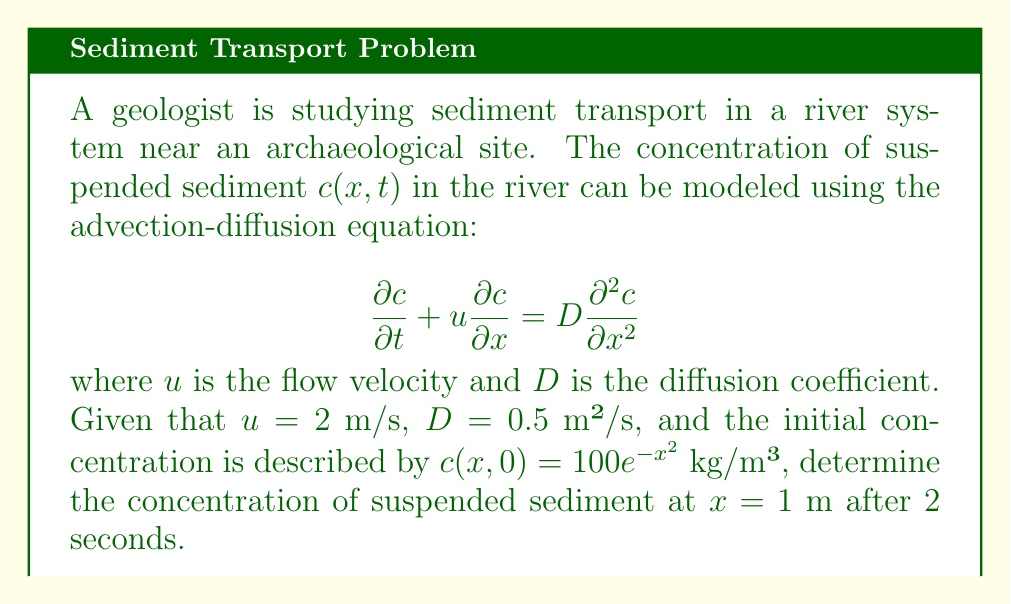Can you solve this math problem? To solve this problem, we need to use the solution to the advection-diffusion equation with the given initial condition. The general solution for this equation is:

$$c(x,t) = \frac{1}{\sqrt{4\pi Dt}} \int_{-\infty}^{\infty} c(\xi,0) \exp\left(-\frac{(x-\xi-ut)^2}{4Dt}\right) d\xi$$

where $c(\xi,0)$ is the initial concentration distribution.

Given:
- Initial concentration: $c(x,0) = 100e^{-x^2}$ kg/m³
- Flow velocity: $u = 2$ m/s
- Diffusion coefficient: $D = 0.5$ m²/s
- Time: $t = 2$ s
- Position: $x = 1$ m

Step 1: Substitute the given values into the general solution:

$$c(1,2) = \frac{1}{\sqrt{4\pi(0.5)(2)}} \int_{-\infty}^{\infty} 100e^{-\xi^2} \exp\left(-\frac{(1-\xi-2(2))^2}{4(0.5)(2)}\right) d\xi$$

Step 2: Simplify the expression:

$$c(1,2) = \frac{100}{\sqrt{2\pi}} \int_{-\infty}^{\infty} e^{-\xi^2} \exp\left(-\frac{(1-\xi-4)^2}{4}\right) d\xi$$

Step 3: Combine the exponents in the integrand:

$$c(1,2) = \frac{100}{\sqrt{2\pi}} \int_{-\infty}^{\infty} \exp\left(-\xi^2 - \frac{(1-\xi-4)^2}{4}\right) d\xi$$

Step 4: Complete the square for the exponent:

$$c(1,2) = \frac{100}{\sqrt{2\pi}} \int_{-\infty}^{\infty} \exp\left(-\frac{5}{4}\xi^2 + \frac{5}{2}\xi - \frac{25}{4}\right) d\xi$$

Step 5: Evaluate the integral:

$$c(1,2) = \frac{100}{\sqrt{2\pi}} \sqrt{\frac{4\pi}{5}} \exp\left(-\frac{5}{4}\right)$$

Step 6: Simplify the expression:

$$c(1,2) = \frac{100}{\sqrt{5}} e^{-\frac{5}{4}} \approx 12.78 \text{ kg/m³}$$
Answer: The concentration of suspended sediment at $x = 1$ m after 2 seconds is approximately 12.78 kg/m³. 